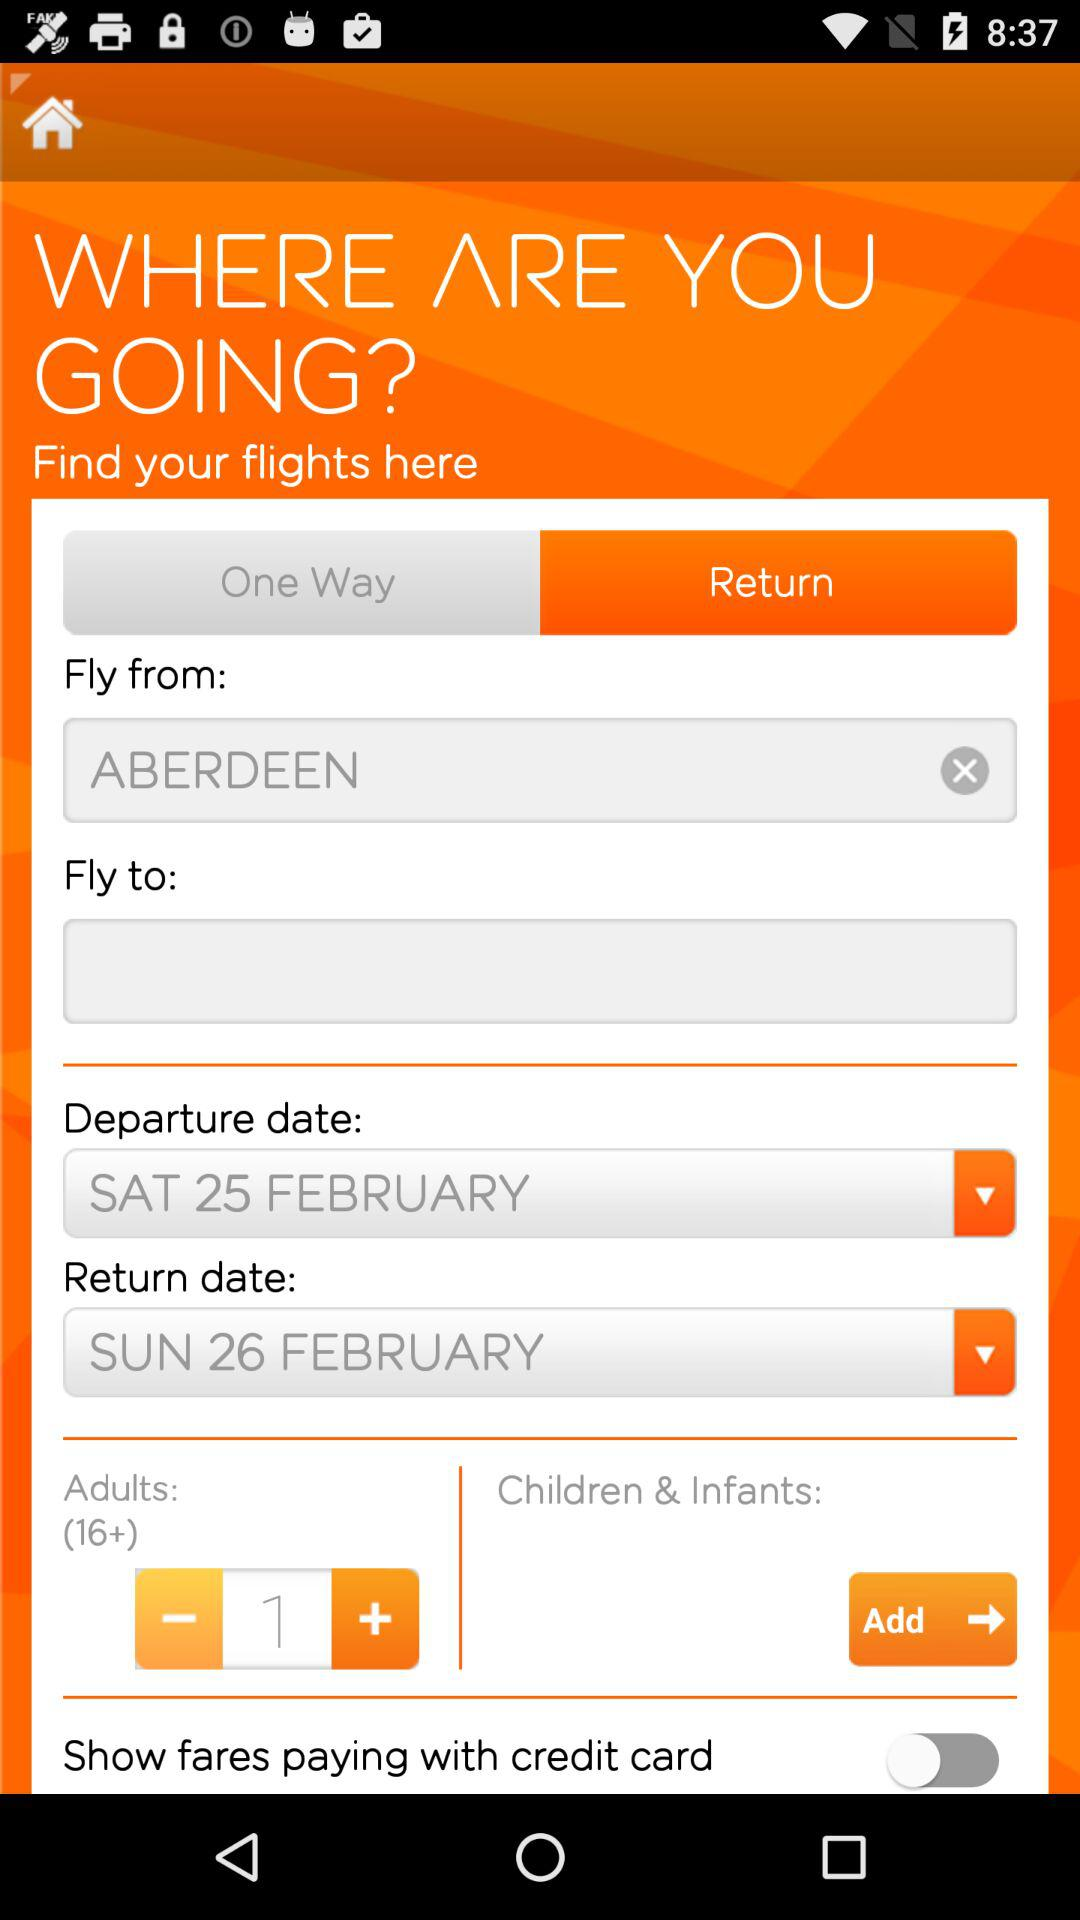How many adult passengers are there? There is 1 adult passenger. 